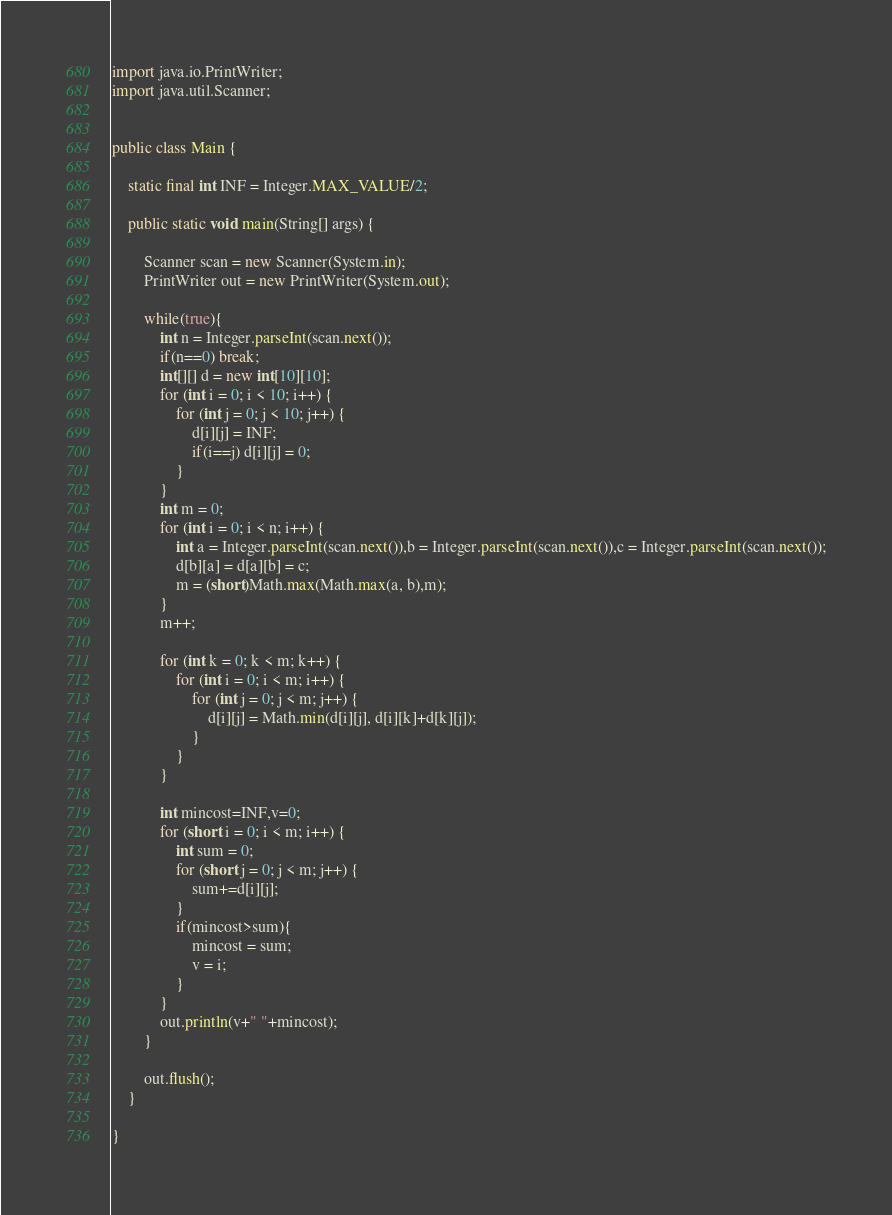<code> <loc_0><loc_0><loc_500><loc_500><_Java_>import java.io.PrintWriter;
import java.util.Scanner;


public class Main {

	static final int INF = Integer.MAX_VALUE/2;

	public static void main(String[] args) {

		Scanner scan = new Scanner(System.in);
		PrintWriter out = new PrintWriter(System.out);

		while(true){
			int n = Integer.parseInt(scan.next());
			if(n==0) break;
			int[][] d = new int[10][10];
			for (int i = 0; i < 10; i++) {
				for (int j = 0; j < 10; j++) {
					d[i][j] = INF;
					if(i==j) d[i][j] = 0;
				}
			}
			int m = 0;
			for (int i = 0; i < n; i++) {
				int a = Integer.parseInt(scan.next()),b = Integer.parseInt(scan.next()),c = Integer.parseInt(scan.next());
				d[b][a] = d[a][b] = c;
				m = (short)Math.max(Math.max(a, b),m);
			}
			m++;

			for (int k = 0; k < m; k++) {
				for (int i = 0; i < m; i++) {
					for (int j = 0; j < m; j++) {
						d[i][j] = Math.min(d[i][j], d[i][k]+d[k][j]);
					}
				}
			}

			int mincost=INF,v=0;
			for (short i = 0; i < m; i++) {
				int sum = 0;
				for (short j = 0; j < m; j++) {
					sum+=d[i][j];
				}
				if(mincost>sum){
					mincost = sum;
					v = i;
				}
			}
			out.println(v+" "+mincost);
		}

		out.flush();
	}

}</code> 